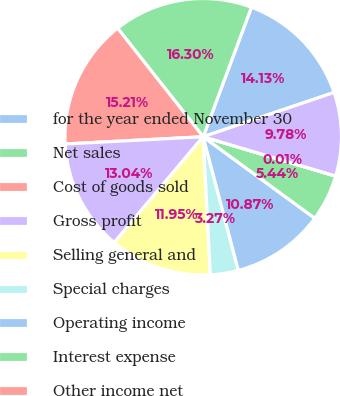Convert chart to OTSL. <chart><loc_0><loc_0><loc_500><loc_500><pie_chart><fcel>for the year ended November 30<fcel>Net sales<fcel>Cost of goods sold<fcel>Gross profit<fcel>Selling general and<fcel>Special charges<fcel>Operating income<fcel>Interest expense<fcel>Other income net<fcel>Income from consolidated<nl><fcel>14.13%<fcel>16.3%<fcel>15.21%<fcel>13.04%<fcel>11.95%<fcel>3.27%<fcel>10.87%<fcel>5.44%<fcel>0.01%<fcel>9.78%<nl></chart> 